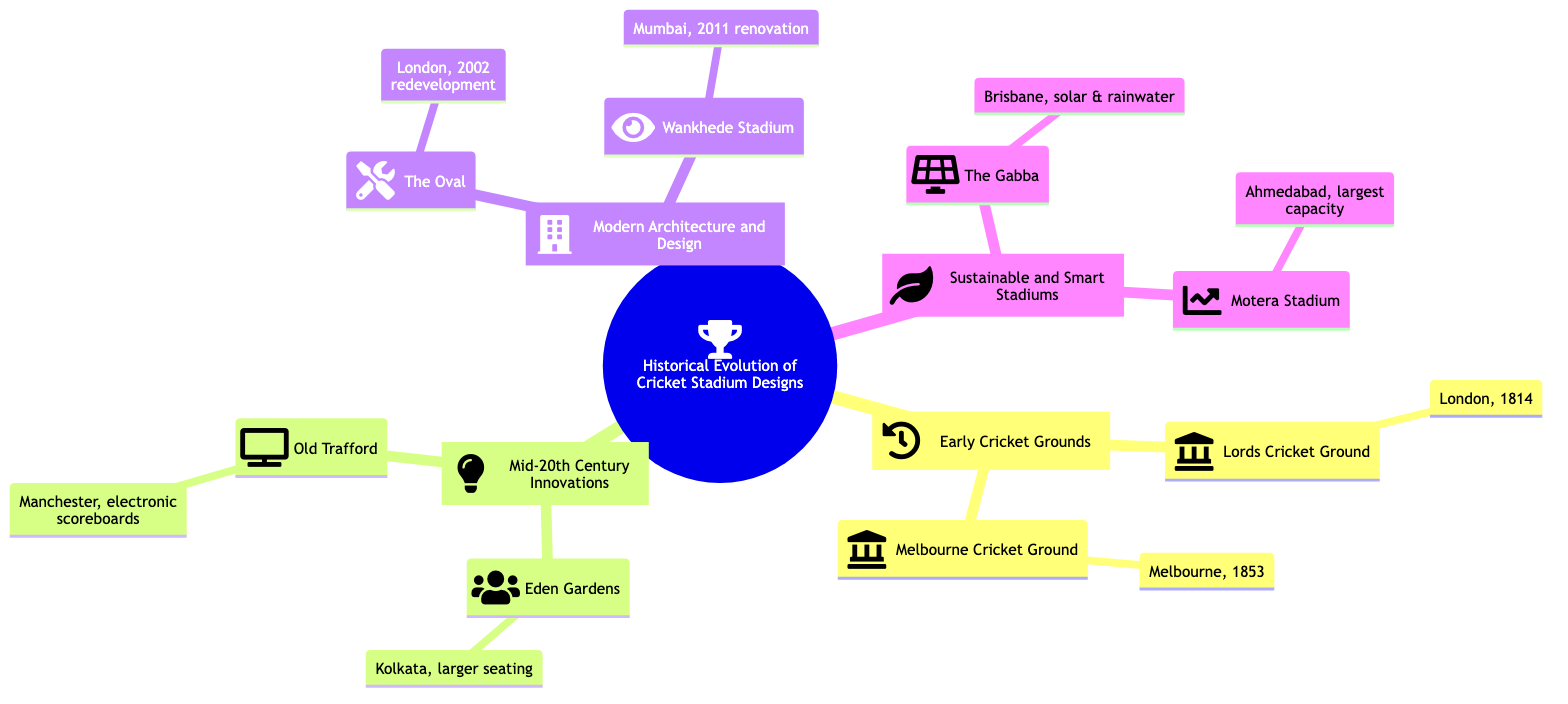What is the location of the Lords Cricket Ground? The diagram indicates that the Lords Cricket Ground is located in London, as noted in the "Early Cricket Grounds" section.
Answer: London What year was the Melbourne Cricket Ground established? According to the diagram, the Melbourne Cricket Ground was established in 1853, as stated under the "Early Cricket Grounds" section.
Answer: 1853 How many stadiums are listed in the "Mid-20th Century Innovations" section? The diagram shows there are two stadiums listed under this section: Eden Gardens and Old Trafford. Therefore, by counting the nodes, the answer is two stadiums.
Answer: 2 Which stadium was renovated in 2011? The diagram specifies that the Wankhede Stadium was renovated in 2011, as mentioned in the "Modern Architecture and Design" section.
Answer: Wankhede Stadium What was introduced at Eden Gardens? The diagram specifies that Eden Gardens introduced larger seating capacities, as outlined in the "Mid-20th Century Innovations" section.
Answer: Larger seating capacities Which stadium in the "Sustainable and Smart Stadiums" section uses solar panels? The diagram states that The Gabba is the stadium that uses solar panels, indicating its commitment to sustainability.
Answer: The Gabba How does the Motera Stadium stand out in terms of capacity? According to the diagram, the Motera Stadium has the world’s largest seating capacity, which makes it notable in the "Sustainable and Smart Stadiums" section.
Answer: World's largest seating capacity In which city is The Oval located? The diagram indicates that The Oval is located in London, as noted in the "Modern Architecture and Design" section.
Answer: London What type of technology was integrated at Old Trafford? The diagram mentions that Old Trafford integrated electronic scoreboards, which represents a significant innovation in cricket stadium design.
Answer: Electronic scoreboards 